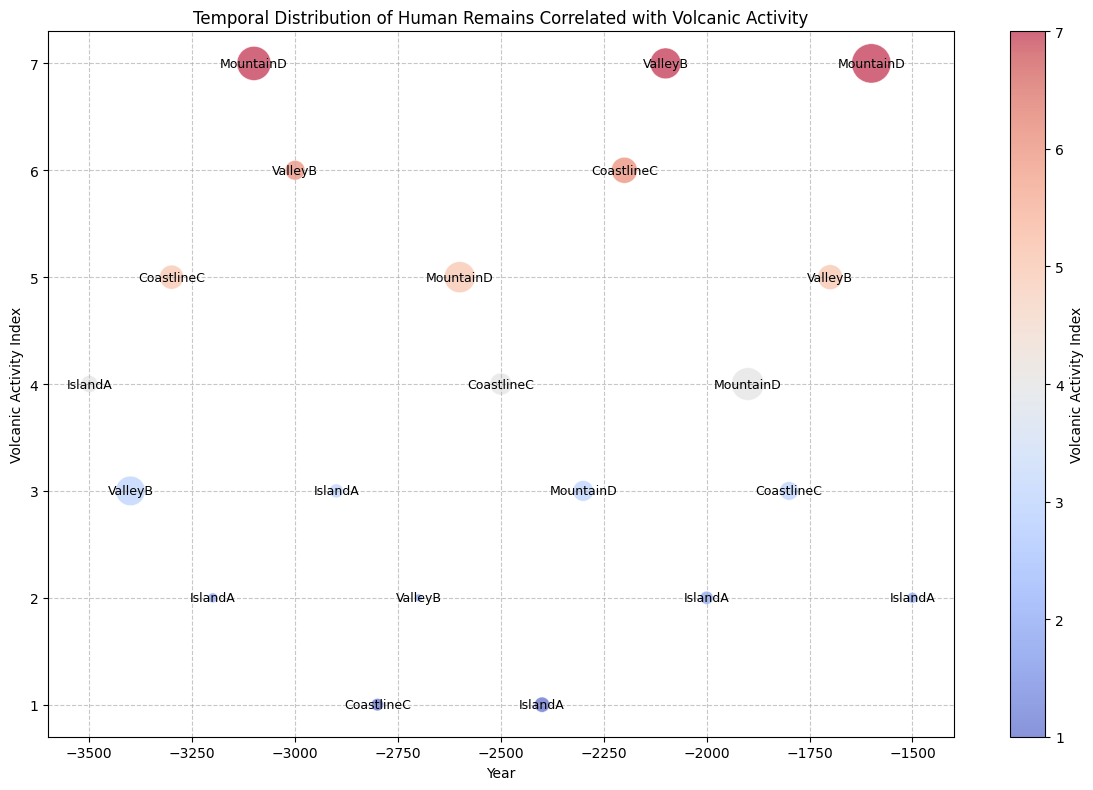What is the range of volcanic activity indices shown in the figure? To determine the range, identify the minimum and maximum volcanic activity indices. The minimum is 1 and the maximum is 7.
Answer: 1 to 7 Which location has the highest count of human remains and what is the associated volcanic activity index? The largest bubble represents the highest count of human remains which is 80 at MountainD, with a volcanic activity index of 7.
Answer: MountainD, 7 Which year has the smallest bubble size and what is the corresponding volcanic activity index? The smallest bubble represents the lowest count of human remains. In the year -2700, with a volcanic activity index of 2, there are 3 human remains.
Answer: -2700, 2 Compare the volcanic activity index of ValleyB in -2100 with MountainD in -2100. Which is higher and by how much? ValleyB has a volcanic activity index of 7 in -2100, and MountainD is not listed for -2100, so the comparison concerns ValleyB alone.
Answer: ValleyB by 7 How does the volcanic activity index in -3100 at MountainD compare to -2200 at CoastlineC? The volcanic activity index at -3100 for MountainD is 7, while at -2200 for CoastlineC it is 6.
Answer: MountainD, 1 higher In which year does IslandA show volcanic activity index 3 and what is the human remains count in that year? IslandA has a volcanic activity index of 3 in -2900, with a human remains count of 10.
Answer: -2900, 10 Which location shows the highest volcanic activity index over the entire period, and what year and index are recorded? MountainD shows the highest volcanic activity index of 7 in both -3100 and -1600.
Answer: MountainD, -3100 and -1600 Considering the years -2600 and -2000, how does the volcanic activity and human remains count compare for IslandA? In -2600, IslandA's volcanic activity index is 3 with 10 human remains, while in -2000 it is 2 with 9 human remains. There's a slight decrease in both metrics.
Answer: Decreased, 1 index unit and 1 human remain Identify the year with the highest human remains count at ValleyB and its associated volcanic activity index. The highest human remains count for ValleyB is 49 in -2100, with a volcanic activity index of 7.
Answer: -2100, 7 From the year -3500 to -1500, how did the volcanic activity at IslandA change? The volcanic activity index at IslandA fluctuates, starting at 4 in -3500 and decreasing to 2 in -1500.
Answer: Decreasing trend 